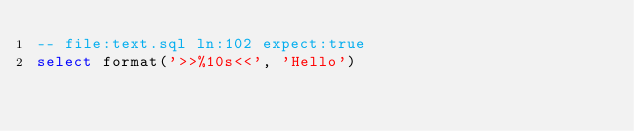<code> <loc_0><loc_0><loc_500><loc_500><_SQL_>-- file:text.sql ln:102 expect:true
select format('>>%10s<<', 'Hello')
</code> 